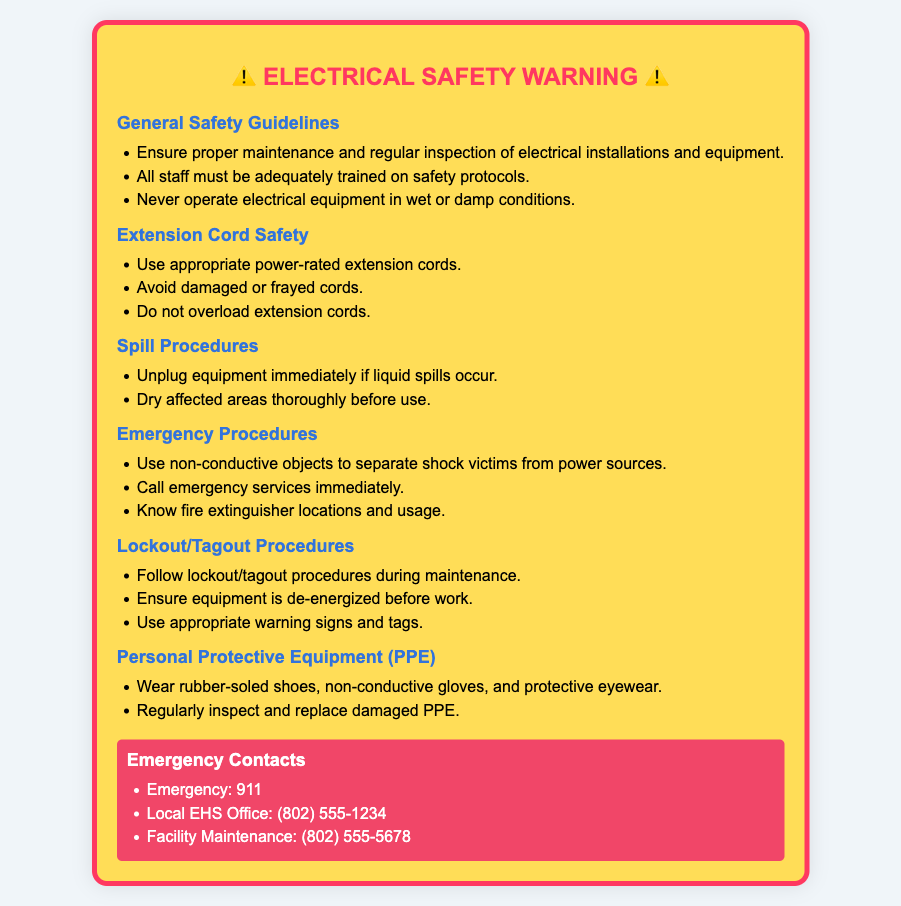What is the background color of the warning label? The background color of the warning label is specifically chosen to stand out and grab attention; it’s mentioned in the document styling.
Answer: #ffdd57 How many safety guidelines are included under General Safety Guidelines? The document lists three specific safety guidelines under the General Safety Guidelines section.
Answer: 3 What should you never do with electrical equipment, according to the safety guidelines? The guideline specifies never to operate electrical equipment under certain hazardous conditions.
Answer: In wet or damp conditions What should you do immediately if liquid spills occur? The procedure outlined provides clear steps to ensure safety in case of spills; the first step is critical in such circumstances.
Answer: Unplug equipment What type of shoes should be worn for personal protective equipment? The section on Personal Protective Equipment specifies the type of shoes recommended for electrical safety.
Answer: Rubber-soled shoes What is the emergency contact number for local EHS Office? The document provides a specific number for immediate contact in emergency situations, which can be crucial for safety.
Answer: (802) 555-1234 What should be used to separate shock victims from power sources? The emergency procedures section indicates a specific type of object that should be utilized in such a crisis to ensure safety.
Answer: Non-conductive objects What is emphasized regarding extension cords? A specific emphasis on the condition of these items is provided in the safety procedures, underlining their importance for safety.
Answer: Avoid damaged or frayed cords How should equipment be managed during maintenance? The document highlights specific procedures that must be followed to ensure safety during maintenance activities.
Answer: Lockout/tagout procedures 